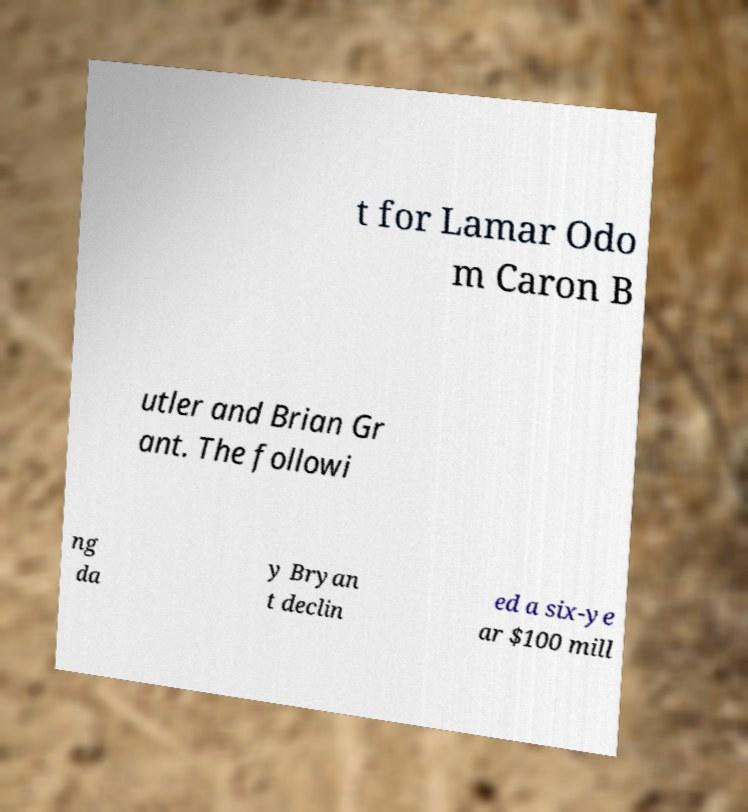Please identify and transcribe the text found in this image. t for Lamar Odo m Caron B utler and Brian Gr ant. The followi ng da y Bryan t declin ed a six-ye ar $100 mill 